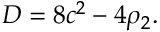<formula> <loc_0><loc_0><loc_500><loc_500>D = 8 c ^ { 2 } - 4 \rho _ { 2 } .</formula> 